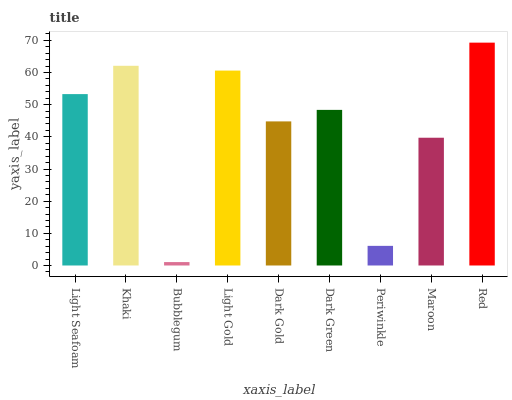Is Bubblegum the minimum?
Answer yes or no. Yes. Is Red the maximum?
Answer yes or no. Yes. Is Khaki the minimum?
Answer yes or no. No. Is Khaki the maximum?
Answer yes or no. No. Is Khaki greater than Light Seafoam?
Answer yes or no. Yes. Is Light Seafoam less than Khaki?
Answer yes or no. Yes. Is Light Seafoam greater than Khaki?
Answer yes or no. No. Is Khaki less than Light Seafoam?
Answer yes or no. No. Is Dark Green the high median?
Answer yes or no. Yes. Is Dark Green the low median?
Answer yes or no. Yes. Is Dark Gold the high median?
Answer yes or no. No. Is Bubblegum the low median?
Answer yes or no. No. 